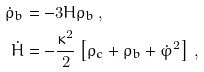Convert formula to latex. <formula><loc_0><loc_0><loc_500><loc_500>\dot { \rho } _ { b } & = - 3 H \rho _ { b } \, , \\ \dot { H } & = - \frac { \kappa ^ { 2 } } { 2 } \left [ \rho _ { c } + \rho _ { b } + \dot { \varphi } ^ { 2 } \right ] \, ,</formula> 